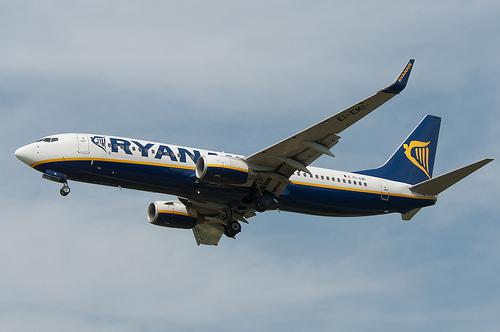Question: when is this?
Choices:
A. Night.
B. Daytime.
C. Noon.
D. Evening.
Answer with the letter. Answer: B Question: why is the airplane in the sky?
Choices:
A. It is going to land.
B. It is in an air show.
C. For spying.
D. It is flying.
Answer with the letter. Answer: D Question: what does the airplane say?
Choices:
A. Jeb.
B. Ryan.
C. Thomas.
D. Obama.
Answer with the letter. Answer: B Question: where is the airplane?
Choices:
A. At the repair shop.
B. In the hangar.
C. On the runway.
D. In the sky.
Answer with the letter. Answer: D Question: who is flying the airplane?
Choices:
A. The computer.
B. The pilot.
C. The engineer.
D. The captain.
Answer with the letter. Answer: B 